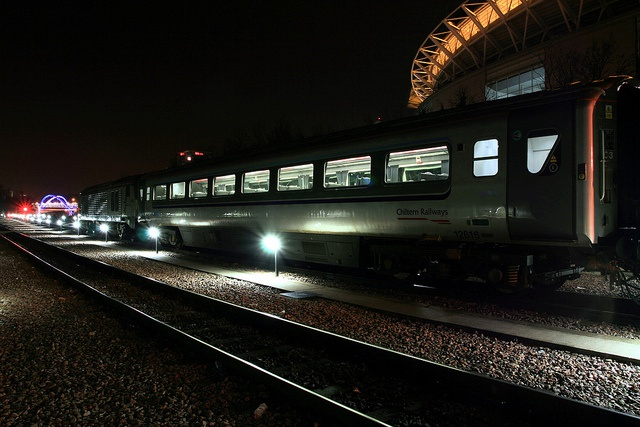Describe the objects in this image and their specific colors. I can see a train in black, gray, ivory, and darkgray tones in this image. 